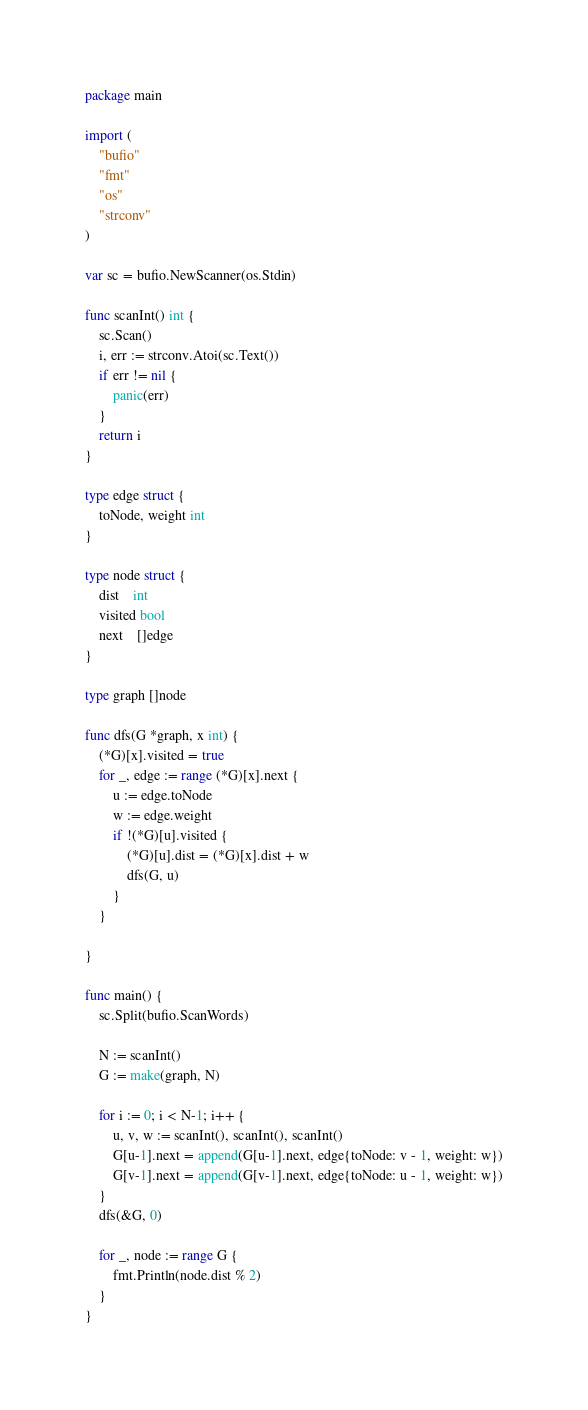Convert code to text. <code><loc_0><loc_0><loc_500><loc_500><_Go_>package main

import (
	"bufio"
	"fmt"
	"os"
	"strconv"
)

var sc = bufio.NewScanner(os.Stdin)

func scanInt() int {
	sc.Scan()
	i, err := strconv.Atoi(sc.Text())
	if err != nil {
		panic(err)
	}
	return i
}

type edge struct {
	toNode, weight int
}

type node struct {
	dist    int
	visited bool
	next    []edge
}

type graph []node

func dfs(G *graph, x int) {
	(*G)[x].visited = true
	for _, edge := range (*G)[x].next {
		u := edge.toNode
		w := edge.weight
		if !(*G)[u].visited {
			(*G)[u].dist = (*G)[x].dist + w
			dfs(G, u)
		}
	}

}

func main() {
	sc.Split(bufio.ScanWords)

	N := scanInt()
	G := make(graph, N)

	for i := 0; i < N-1; i++ {
		u, v, w := scanInt(), scanInt(), scanInt()
		G[u-1].next = append(G[u-1].next, edge{toNode: v - 1, weight: w})
		G[v-1].next = append(G[v-1].next, edge{toNode: u - 1, weight: w})
	}
	dfs(&G, 0)

	for _, node := range G {
		fmt.Println(node.dist % 2)
	}
}
</code> 